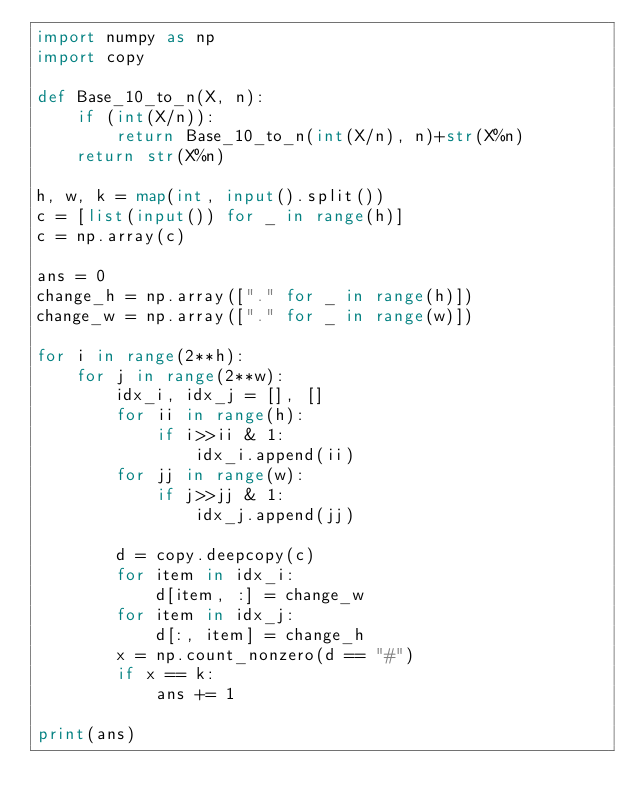Convert code to text. <code><loc_0><loc_0><loc_500><loc_500><_Python_>import numpy as np
import copy

def Base_10_to_n(X, n):
    if (int(X/n)):
        return Base_10_to_n(int(X/n), n)+str(X%n)
    return str(X%n)

h, w, k = map(int, input().split())
c = [list(input()) for _ in range(h)]
c = np.array(c)

ans = 0
change_h = np.array(["." for _ in range(h)])
change_w = np.array(["." for _ in range(w)])

for i in range(2**h):
    for j in range(2**w):
        idx_i, idx_j = [], []
        for ii in range(h):
            if i>>ii & 1:
                idx_i.append(ii)
        for jj in range(w):
            if j>>jj & 1:
                idx_j.append(jj)

        d = copy.deepcopy(c)
        for item in idx_i:
            d[item, :] = change_w
        for item in idx_j:
            d[:, item] = change_h
        x = np.count_nonzero(d == "#")
        if x == k:
            ans += 1
        
print(ans)</code> 